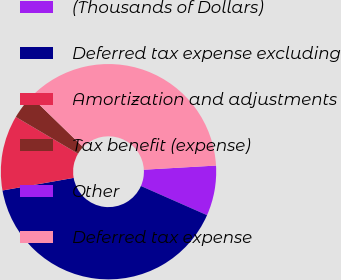Convert chart. <chart><loc_0><loc_0><loc_500><loc_500><pie_chart><fcel>(Thousands of Dollars)<fcel>Deferred tax expense excluding<fcel>Amortization and adjustments<fcel>Tax benefit (expense)<fcel>Other<fcel>Deferred tax expense<nl><fcel>7.52%<fcel>40.6%<fcel>11.28%<fcel>3.76%<fcel>0.0%<fcel>36.84%<nl></chart> 